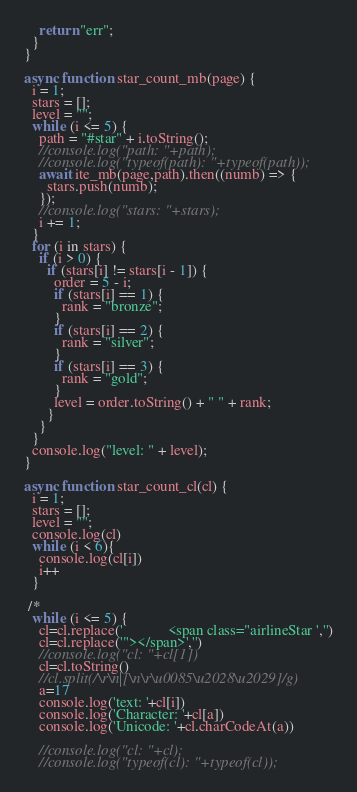Convert code to text. <code><loc_0><loc_0><loc_500><loc_500><_JavaScript_>    return "err";
  }
}

async function star_count_mb(page) {
  i = 1;
  stars = [];
  level = "";
  while (i <= 5) {
    path = "#star" + i.toString();
    //console.log("path: "+path);
    //console.log("typeof(path): "+typeof(path));
    await ite_mb(page,path).then((numb) => {
      stars.push(numb);
    });
    //console.log("stars: "+stars);
    i += 1;
  }
  for (i in stars) {
    if (i > 0) {
      if (stars[i] != stars[i - 1]) {
        order = 5 - i;
        if (stars[i] == 1) {
          rank = "bronze";
        }
        if (stars[i] == 2) {
          rank = "silver";
        }
        if (stars[i] == 3) {
          rank = "gold";
        }
        level = order.toString() + " " + rank;
      }
    }
  }
  console.log("level: " + level);
}

async function star_count_cl(cl) {
  i = 1;
  stars = [];
  level = "";
  console.log(cl)
  while (i < 6){
    console.log(cl[i])
    i++
  }
  
 /* 
  while (i <= 5) {
    cl=cl.replace('            <span class="airlineStar ','')
    cl=cl.replace('"></span>','')
    //console.log("cl: "+cl[1])
    cl=cl.toString()
    //cl.split(/\r\n|[\n\r\u0085\u2028\u2029]/g)
    a=17
    console.log('text: '+cl[i])
    console.log('Character: '+cl[a])
    console.log('Unicode: '+cl.charCodeAt(a))

    //console.log("cl: "+cl);
    //console.log("typeof(cl): "+typeof(cl));</code> 